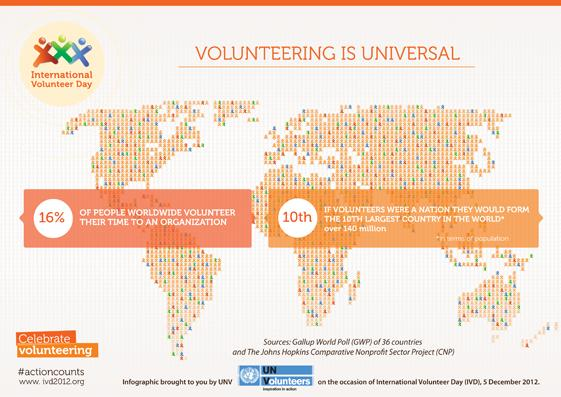Give some essential details in this illustration. According to the count, there are 140 million volunteers. Today we celebrate International Volunteer Day, a day to recognize and honor the contributions of volunteers around the world. 